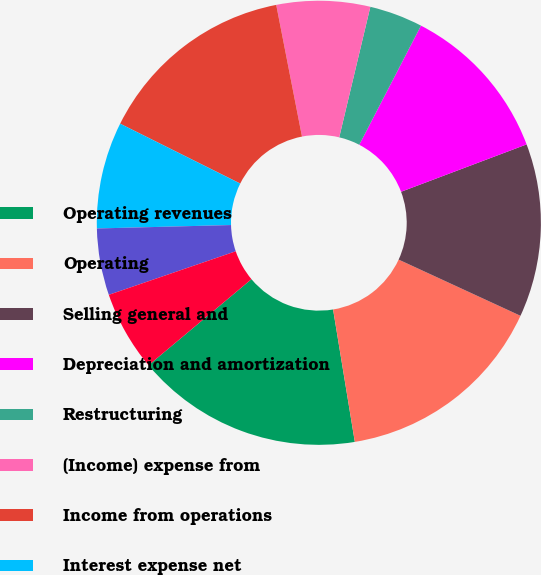Convert chart to OTSL. <chart><loc_0><loc_0><loc_500><loc_500><pie_chart><fcel>Operating revenues<fcel>Operating<fcel>Selling general and<fcel>Depreciation and amortization<fcel>Restructuring<fcel>(Income) expense from<fcel>Income from operations<fcel>Interest expense net<fcel>Equity in net losses of<fcel>Other net<nl><fcel>16.5%<fcel>15.53%<fcel>12.62%<fcel>11.65%<fcel>3.88%<fcel>6.8%<fcel>14.56%<fcel>7.77%<fcel>4.85%<fcel>5.83%<nl></chart> 